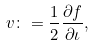<formula> <loc_0><loc_0><loc_500><loc_500>v \colon = \frac { 1 } { 2 } \frac { \partial f } { \partial \iota } ,</formula> 